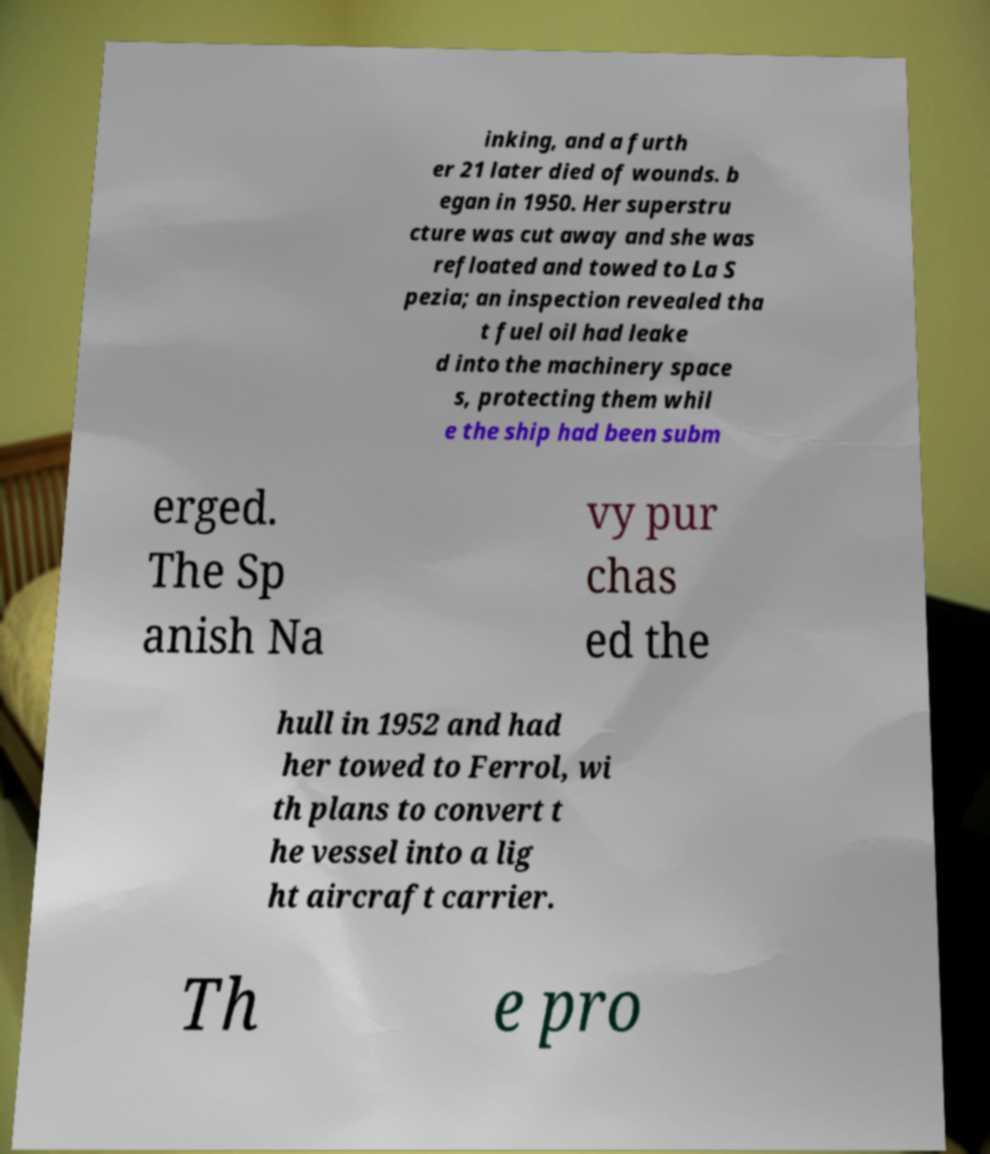I need the written content from this picture converted into text. Can you do that? inking, and a furth er 21 later died of wounds. b egan in 1950. Her superstru cture was cut away and she was refloated and towed to La S pezia; an inspection revealed tha t fuel oil had leake d into the machinery space s, protecting them whil e the ship had been subm erged. The Sp anish Na vy pur chas ed the hull in 1952 and had her towed to Ferrol, wi th plans to convert t he vessel into a lig ht aircraft carrier. Th e pro 